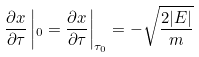<formula> <loc_0><loc_0><loc_500><loc_500>\frac { \partial x } { \partial \tau } \left | _ { 0 } = \frac { \partial x } { \partial \tau } \right | _ { \tau _ { 0 } } = - \sqrt { \frac { 2 | E | } { m } }</formula> 